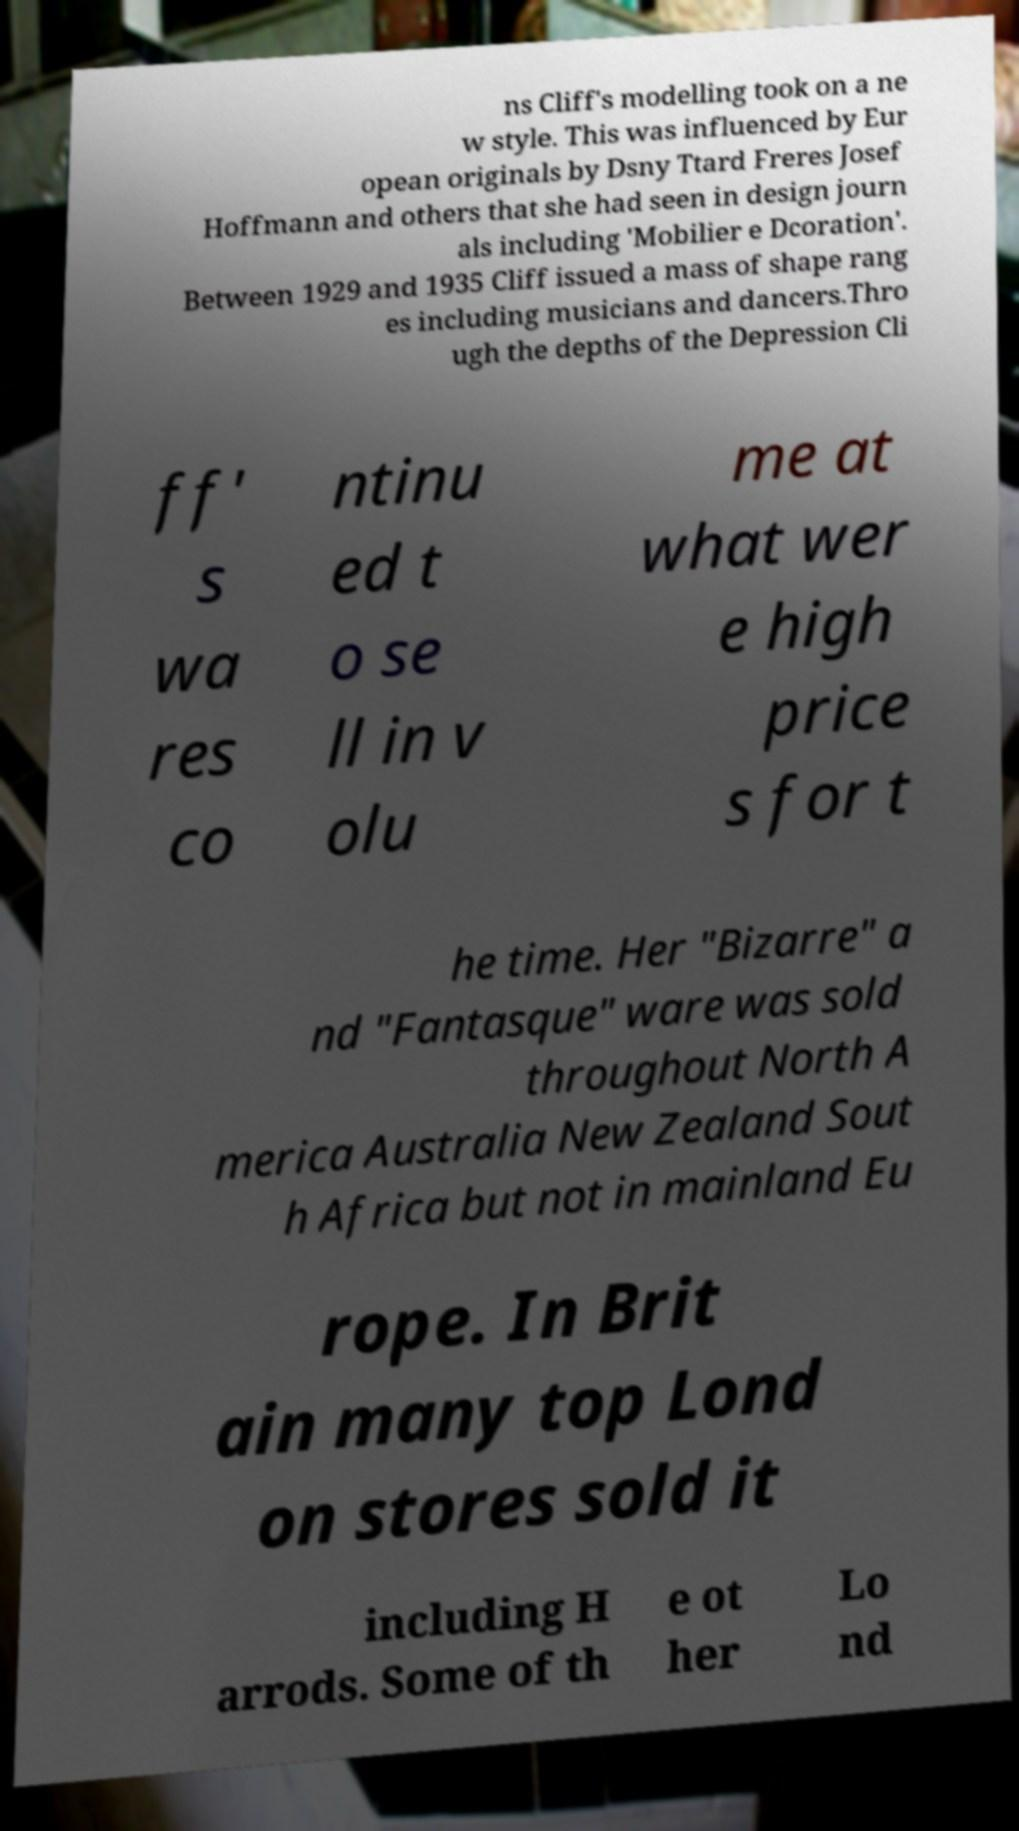I need the written content from this picture converted into text. Can you do that? ns Cliff's modelling took on a ne w style. This was influenced by Eur opean originals by Dsny Ttard Freres Josef Hoffmann and others that she had seen in design journ als including 'Mobilier e Dcoration'. Between 1929 and 1935 Cliff issued a mass of shape rang es including musicians and dancers.Thro ugh the depths of the Depression Cli ff' s wa res co ntinu ed t o se ll in v olu me at what wer e high price s for t he time. Her "Bizarre" a nd "Fantasque" ware was sold throughout North A merica Australia New Zealand Sout h Africa but not in mainland Eu rope. In Brit ain many top Lond on stores sold it including H arrods. Some of th e ot her Lo nd 